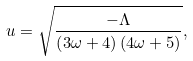<formula> <loc_0><loc_0><loc_500><loc_500>u = \sqrt { \frac { - \Lambda } { \left ( 3 \omega + 4 \right ) \left ( 4 \omega + 5 \right ) } } ,</formula> 